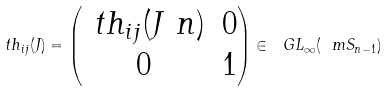<formula> <loc_0><loc_0><loc_500><loc_500>\ t h _ { i j } ( J ) = \left ( \begin{matrix} \ t h _ { i j } ( J \ n ) & 0 \\ 0 & 1 \end{matrix} \right ) \in \ G L _ { \infty } ( \ m S _ { n - 1 } )</formula> 